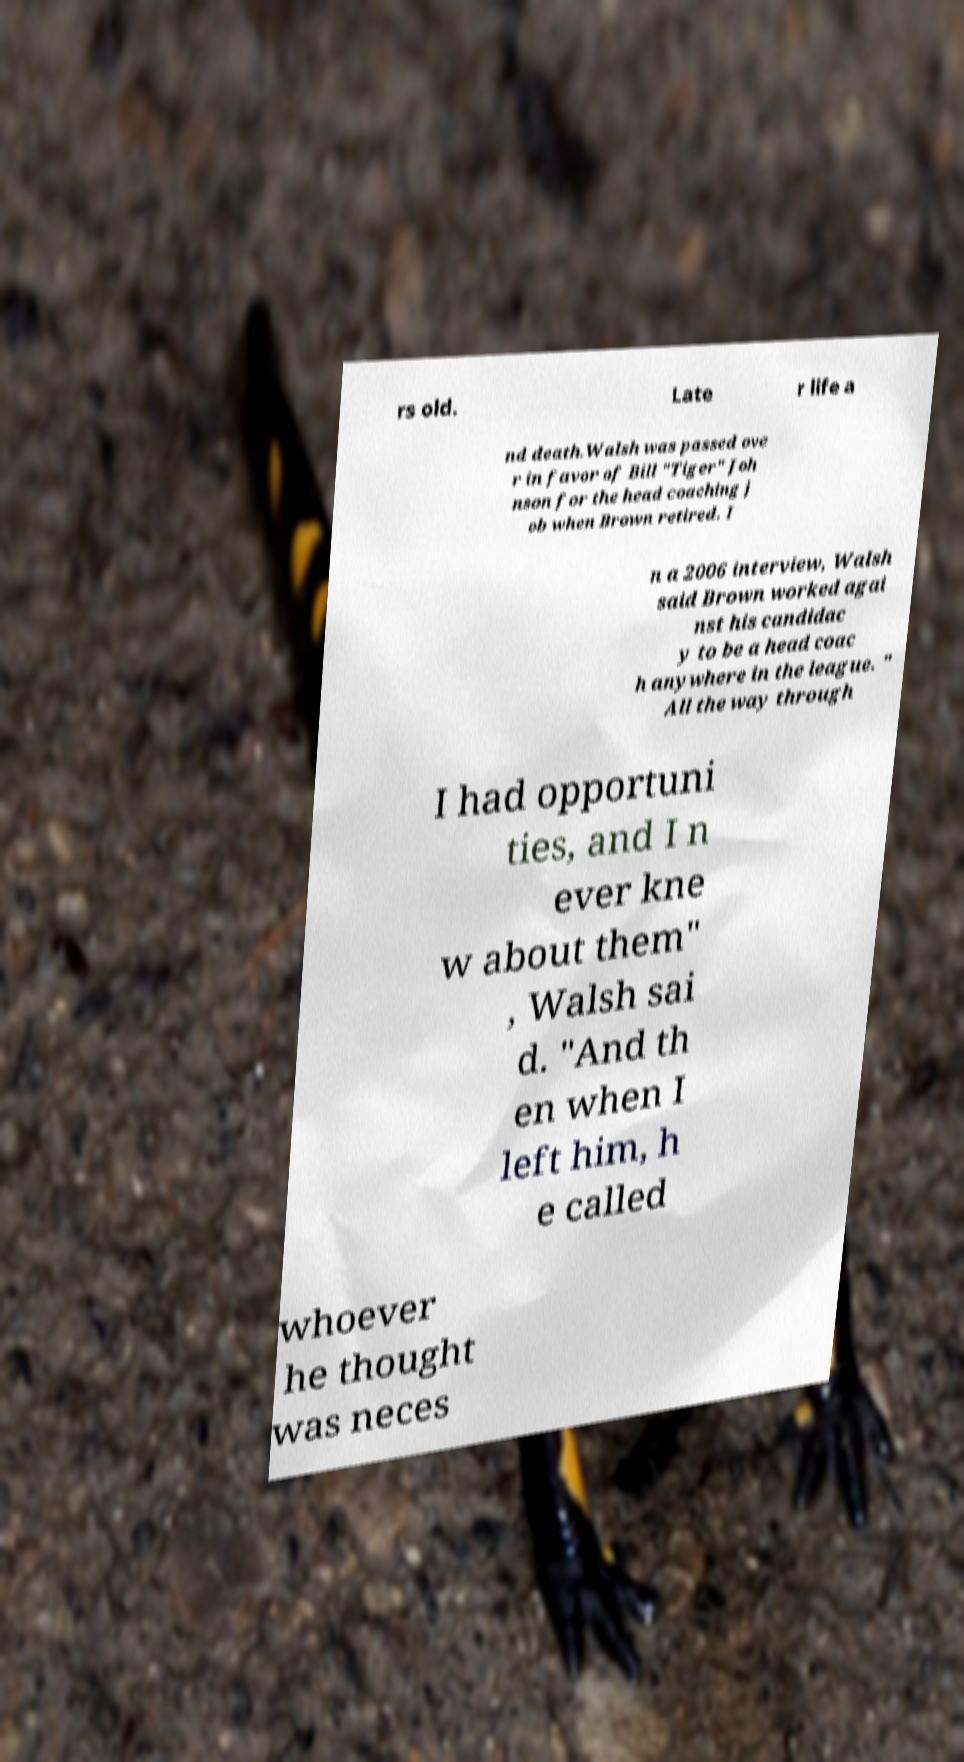Can you read and provide the text displayed in the image?This photo seems to have some interesting text. Can you extract and type it out for me? rs old. Late r life a nd death.Walsh was passed ove r in favor of Bill "Tiger" Joh nson for the head coaching j ob when Brown retired. I n a 2006 interview, Walsh said Brown worked agai nst his candidac y to be a head coac h anywhere in the league. " All the way through I had opportuni ties, and I n ever kne w about them" , Walsh sai d. "And th en when I left him, h e called whoever he thought was neces 